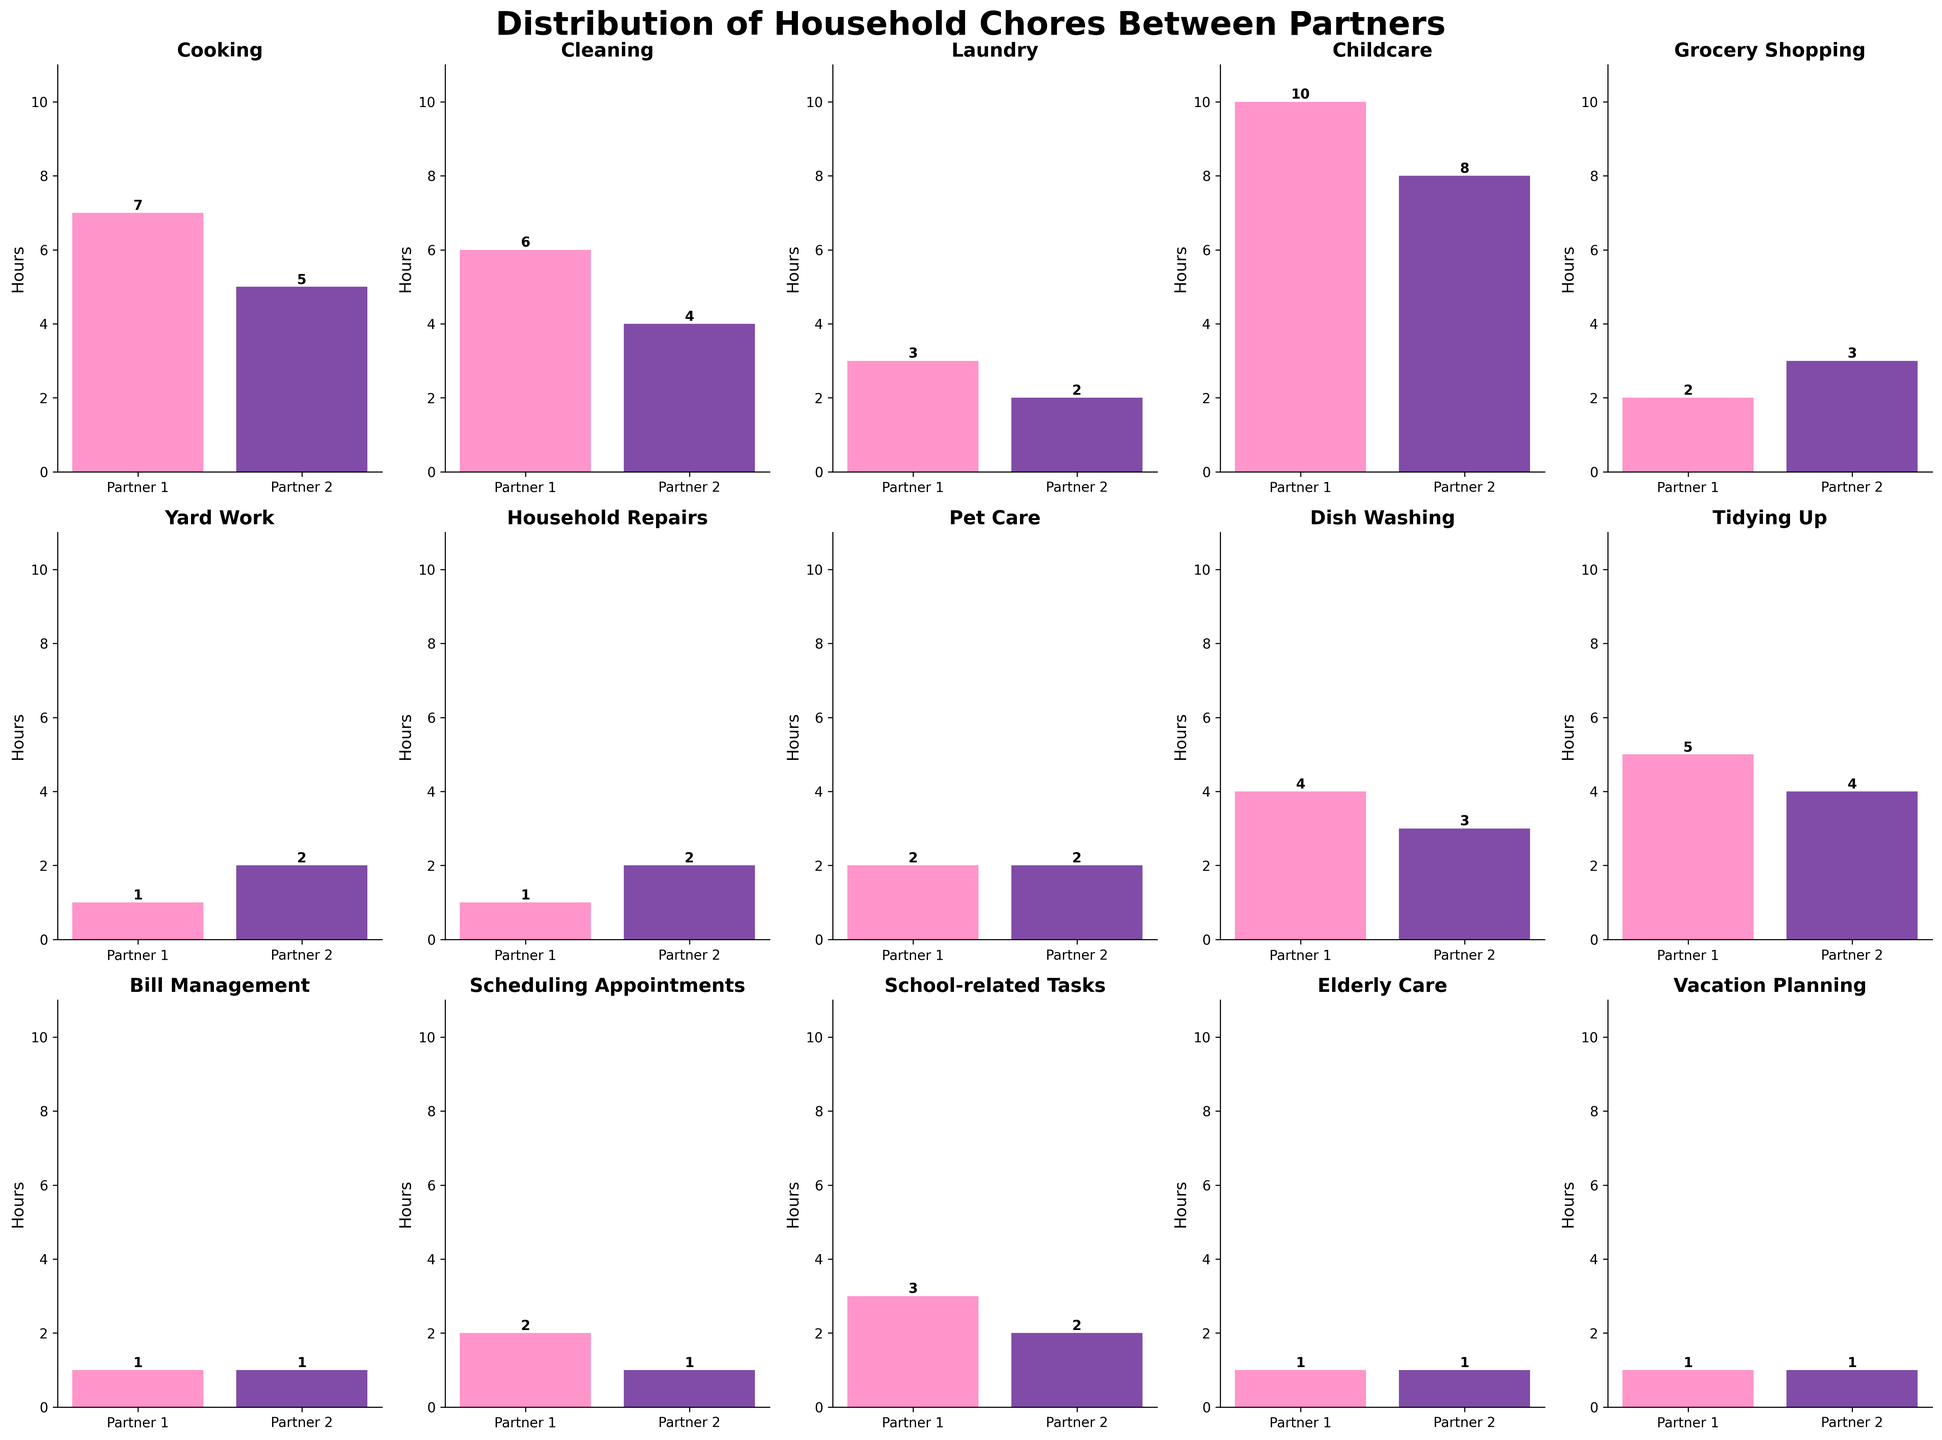What's the title of the figure? The title of the figure is located at the top center and reads "Distribution of Household Chores Between Partners".
Answer: Distribution of Household Chores Between Partners How many chores have equal hours allocated between both partners? By checking each subplot, you can see that the following chores have equal hours: Pet Care, Bill Management, Elderly Care, and Vacation Planning, making a total of 4 chores.
Answer: 4 Which partner spends more hours on grocery shopping? By observing the "Grocery Shopping" subplot, it's clear that Partner 2 spends 3 hours while Partner 1 spends 2 hours, so Partner 2 spends more hours on grocery shopping.
Answer: Partner 2 What is the total number of hours spent on childcare by both partners combined? For the "Childcare" subplot, Partner 1 spends 10 hours and Partner 2 spends 8 hours. Summing these gives 10 + 8 = 18.
Answer: 18 Which chore has the biggest difference in hours between partners, and what's that difference? By examining each subplot, the chore with the biggest difference is "Cooking," where Partner 1 spends 7 hours and Partner 2 spends only 5 hours. The difference is 7 - 5 = 2.
Answer: Cooking, 2 How many chores does Partner 1 spend more hours on compared to Partner 2? Partner 1 spends more hours on Cooking, Cleaning, Laundry, Childcare, Dish Washing, Tidying Up, School-related Tasks, and Scheduling Appointments, totaling 8 chores.
Answer: 8 In which chore do both partners contribute equally for the smallest number of hours? By checking the subplots where hours are equal, "Bill Management," "Elderly Care," and "Vacation Planning" all show both partners contributing equally for 1 hour, which is the smallest number of hours among all equal chores.
Answer: Bill Management, Elderly Care, Vacation Planning Which chores have Partner 2 working more hours than Partner 1? Partner 2 spends more hours on Grocery Shopping and Yard Work.
Answer: Grocery Shopping, Yard Work What's the combined total number of hours Partner 1 spends on Cooking, Cleaning, and Laundry? For Cooking, Partner 1 spends 7 hours; for Cleaning, 6 hours; and for Laundry, 3 hours. Summing these gives 7 + 6 + 3 = 16.
Answer: 16 Which partner spends more time on Tidying Up and by how much? In the "Tidying Up" subplot, Partner 1 spends 5 hours while Partner 2 spends 4 hours. The difference is 5 - 4 = 1.
Answer: Partner 1, 1 